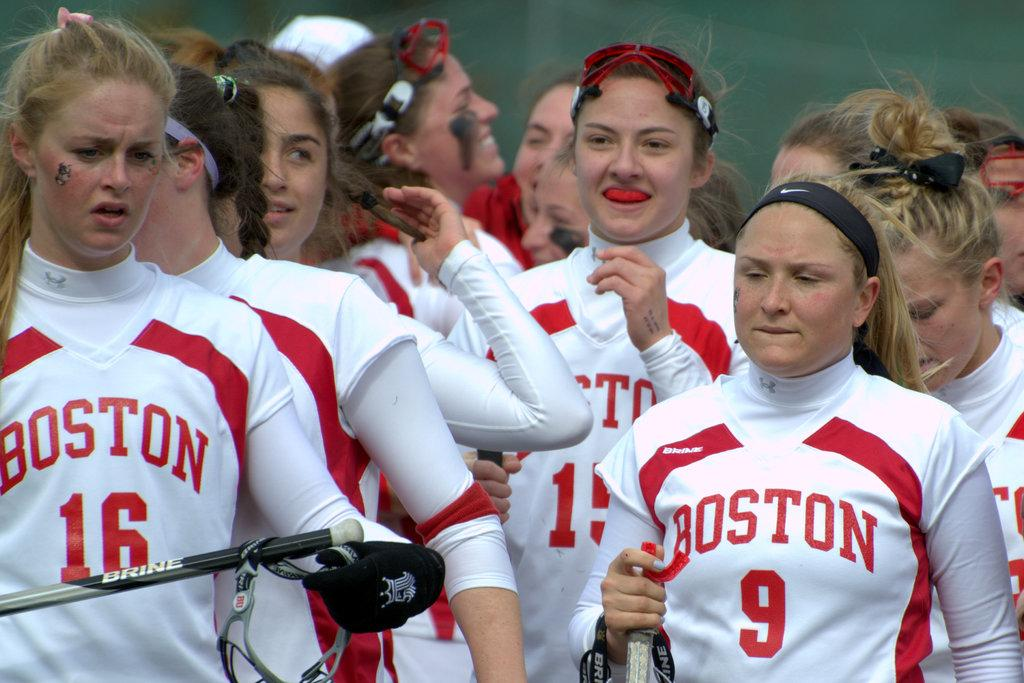Provide a one-sentence caption for the provided image. a few girls that are wearing Boston uniforms. 